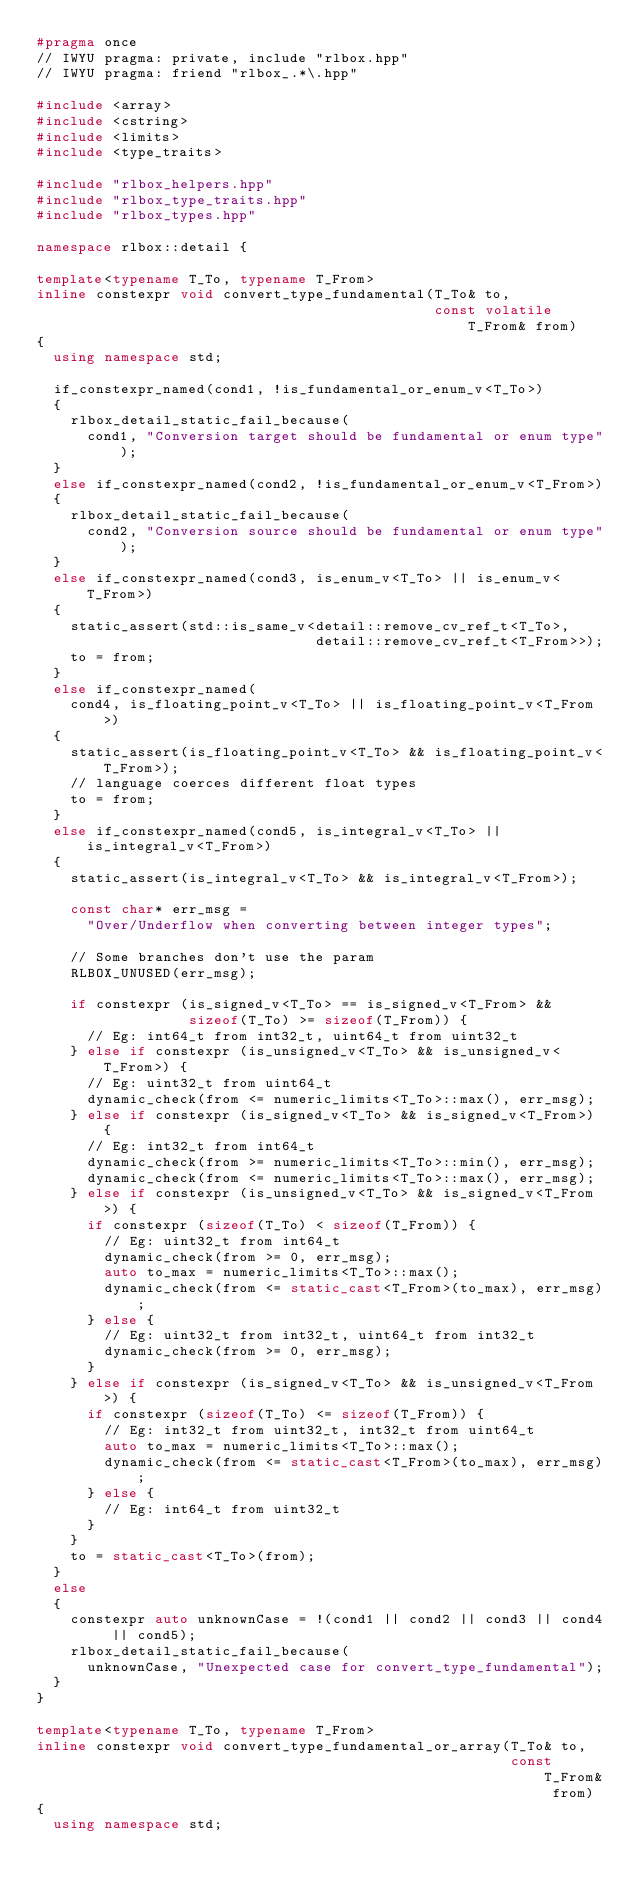Convert code to text. <code><loc_0><loc_0><loc_500><loc_500><_C++_>#pragma once
// IWYU pragma: private, include "rlbox.hpp"
// IWYU pragma: friend "rlbox_.*\.hpp"

#include <array>
#include <cstring>
#include <limits>
#include <type_traits>

#include "rlbox_helpers.hpp"
#include "rlbox_type_traits.hpp"
#include "rlbox_types.hpp"

namespace rlbox::detail {

template<typename T_To, typename T_From>
inline constexpr void convert_type_fundamental(T_To& to,
                                               const volatile T_From& from)
{
  using namespace std;

  if_constexpr_named(cond1, !is_fundamental_or_enum_v<T_To>)
  {
    rlbox_detail_static_fail_because(
      cond1, "Conversion target should be fundamental or enum type");
  }
  else if_constexpr_named(cond2, !is_fundamental_or_enum_v<T_From>)
  {
    rlbox_detail_static_fail_because(
      cond2, "Conversion source should be fundamental or enum type");
  }
  else if_constexpr_named(cond3, is_enum_v<T_To> || is_enum_v<T_From>)
  {
    static_assert(std::is_same_v<detail::remove_cv_ref_t<T_To>,
                                 detail::remove_cv_ref_t<T_From>>);
    to = from;
  }
  else if_constexpr_named(
    cond4, is_floating_point_v<T_To> || is_floating_point_v<T_From>)
  {
    static_assert(is_floating_point_v<T_To> && is_floating_point_v<T_From>);
    // language coerces different float types
    to = from;
  }
  else if_constexpr_named(cond5, is_integral_v<T_To> || is_integral_v<T_From>)
  {
    static_assert(is_integral_v<T_To> && is_integral_v<T_From>);

    const char* err_msg =
      "Over/Underflow when converting between integer types";

    // Some branches don't use the param
    RLBOX_UNUSED(err_msg);

    if constexpr (is_signed_v<T_To> == is_signed_v<T_From> &&
                  sizeof(T_To) >= sizeof(T_From)) {
      // Eg: int64_t from int32_t, uint64_t from uint32_t
    } else if constexpr (is_unsigned_v<T_To> && is_unsigned_v<T_From>) {
      // Eg: uint32_t from uint64_t
      dynamic_check(from <= numeric_limits<T_To>::max(), err_msg);
    } else if constexpr (is_signed_v<T_To> && is_signed_v<T_From>) {
      // Eg: int32_t from int64_t
      dynamic_check(from >= numeric_limits<T_To>::min(), err_msg);
      dynamic_check(from <= numeric_limits<T_To>::max(), err_msg);
    } else if constexpr (is_unsigned_v<T_To> && is_signed_v<T_From>) {
      if constexpr (sizeof(T_To) < sizeof(T_From)) {
        // Eg: uint32_t from int64_t
        dynamic_check(from >= 0, err_msg);
        auto to_max = numeric_limits<T_To>::max();
        dynamic_check(from <= static_cast<T_From>(to_max), err_msg);
      } else {
        // Eg: uint32_t from int32_t, uint64_t from int32_t
        dynamic_check(from >= 0, err_msg);
      }
    } else if constexpr (is_signed_v<T_To> && is_unsigned_v<T_From>) {
      if constexpr (sizeof(T_To) <= sizeof(T_From)) {
        // Eg: int32_t from uint32_t, int32_t from uint64_t
        auto to_max = numeric_limits<T_To>::max();
        dynamic_check(from <= static_cast<T_From>(to_max), err_msg);
      } else {
        // Eg: int64_t from uint32_t
      }
    }
    to = static_cast<T_To>(from);
  }
  else
  {
    constexpr auto unknownCase = !(cond1 || cond2 || cond3 || cond4 || cond5);
    rlbox_detail_static_fail_because(
      unknownCase, "Unexpected case for convert_type_fundamental");
  }
}

template<typename T_To, typename T_From>
inline constexpr void convert_type_fundamental_or_array(T_To& to,
                                                        const T_From& from)
{
  using namespace std;
</code> 